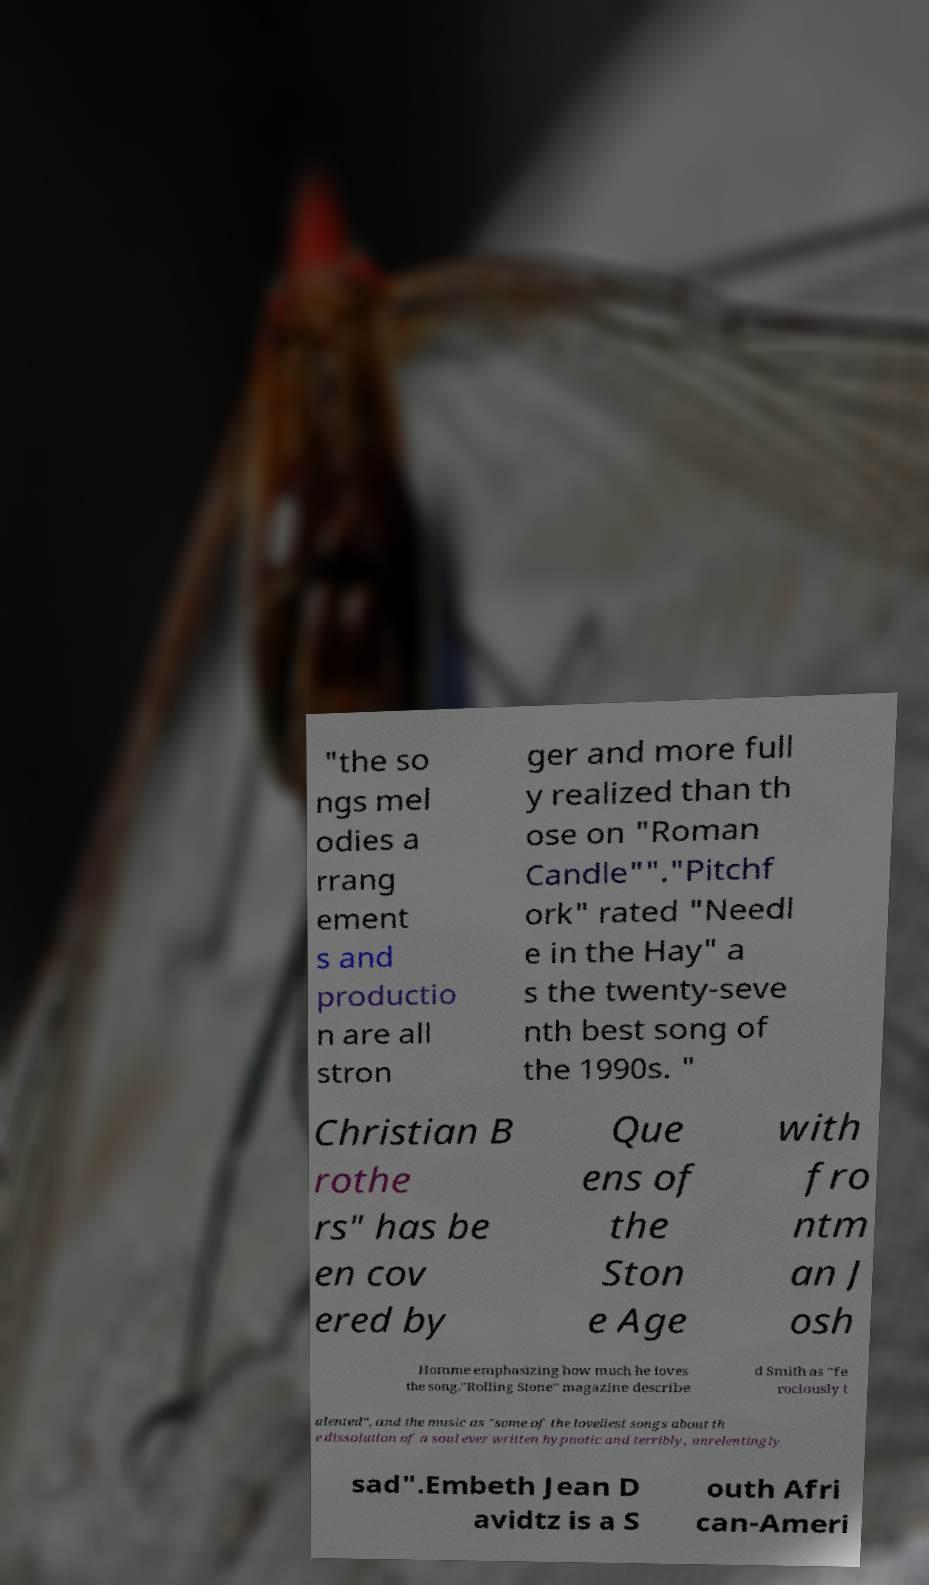I need the written content from this picture converted into text. Can you do that? "the so ngs mel odies a rrang ement s and productio n are all stron ger and more full y realized than th ose on "Roman Candle""."Pitchf ork" rated "Needl e in the Hay" a s the twenty-seve nth best song of the 1990s. " Christian B rothe rs" has be en cov ered by Que ens of the Ston e Age with fro ntm an J osh Homme emphasizing how much he loves the song."Rolling Stone" magazine describe d Smith as "fe rociously t alented", and the music as "some of the loveliest songs about th e dissolution of a soul ever written hypnotic and terribly, unrelentingly sad".Embeth Jean D avidtz is a S outh Afri can-Ameri 